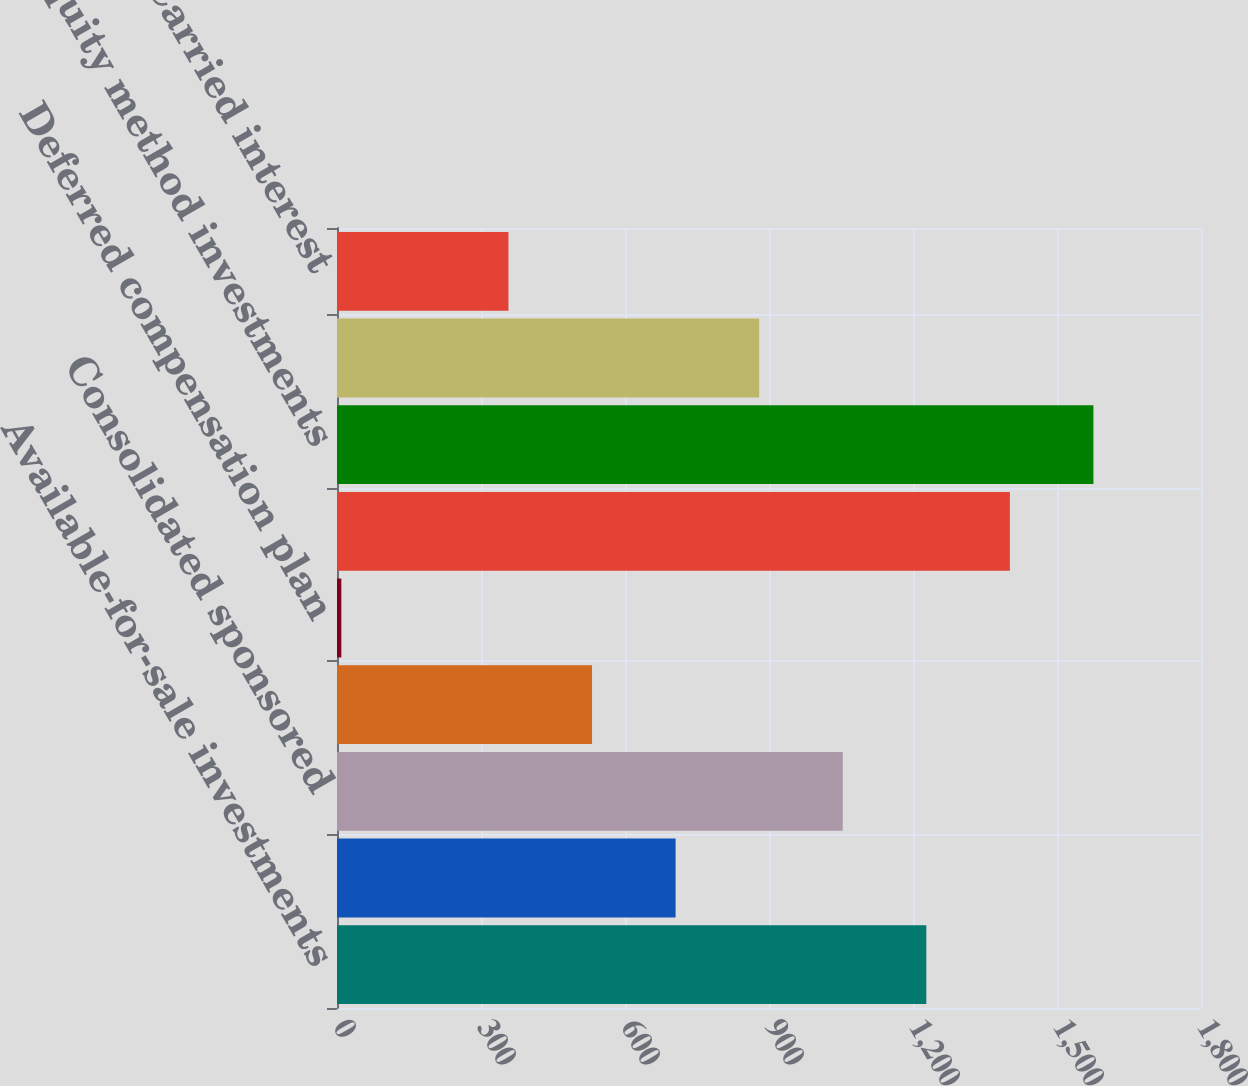Convert chart. <chart><loc_0><loc_0><loc_500><loc_500><bar_chart><fcel>Available-for-sale investments<fcel>Held-to-maturity investments<fcel>Consolidated sponsored<fcel>Other equity and debt<fcel>Deferred compensation plan<fcel>Total trading investments<fcel>Equity method investments<fcel>Cost method investments (1)<fcel>Carried interest<nl><fcel>1227.7<fcel>705.4<fcel>1053.6<fcel>531.3<fcel>9<fcel>1401.8<fcel>1575.9<fcel>879.5<fcel>357.2<nl></chart> 